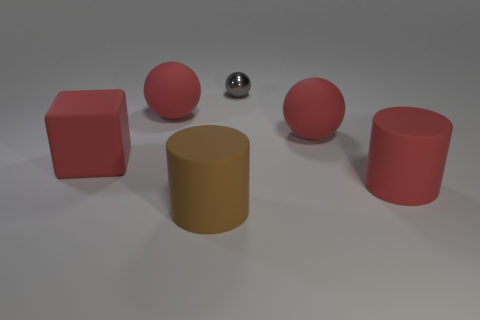Are there any other things that have the same material as the small gray sphere?
Ensure brevity in your answer.  No. How many large red rubber balls are both right of the metallic thing and left of the gray sphere?
Make the answer very short. 0. Do the big red cylinder and the cylinder that is to the left of the large red rubber cylinder have the same material?
Offer a terse response. Yes. How many gray things are either large matte spheres or big matte objects?
Ensure brevity in your answer.  0. Is there a cylinder of the same size as the brown object?
Offer a very short reply. Yes. There is a large cylinder that is behind the large matte cylinder that is on the left side of the red thing that is in front of the red cube; what is it made of?
Offer a very short reply. Rubber. Is the number of rubber spheres that are on the right side of the shiny sphere the same as the number of big rubber balls?
Give a very brief answer. No. Is the ball that is to the left of the large brown matte cylinder made of the same material as the red ball that is on the right side of the gray metal sphere?
Make the answer very short. Yes. How many things are large brown balls or rubber cylinders that are in front of the large red cylinder?
Offer a very short reply. 1. Is there a big brown matte thing of the same shape as the small object?
Ensure brevity in your answer.  No. 